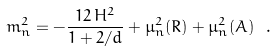Convert formula to latex. <formula><loc_0><loc_0><loc_500><loc_500>m _ { n } ^ { 2 } = - \frac { 1 2 \, H ^ { 2 } } { 1 + 2 / d } + \mu ^ { 2 } _ { n } ( R ) + \mu ^ { 2 } _ { n } ( A ) \ .</formula> 